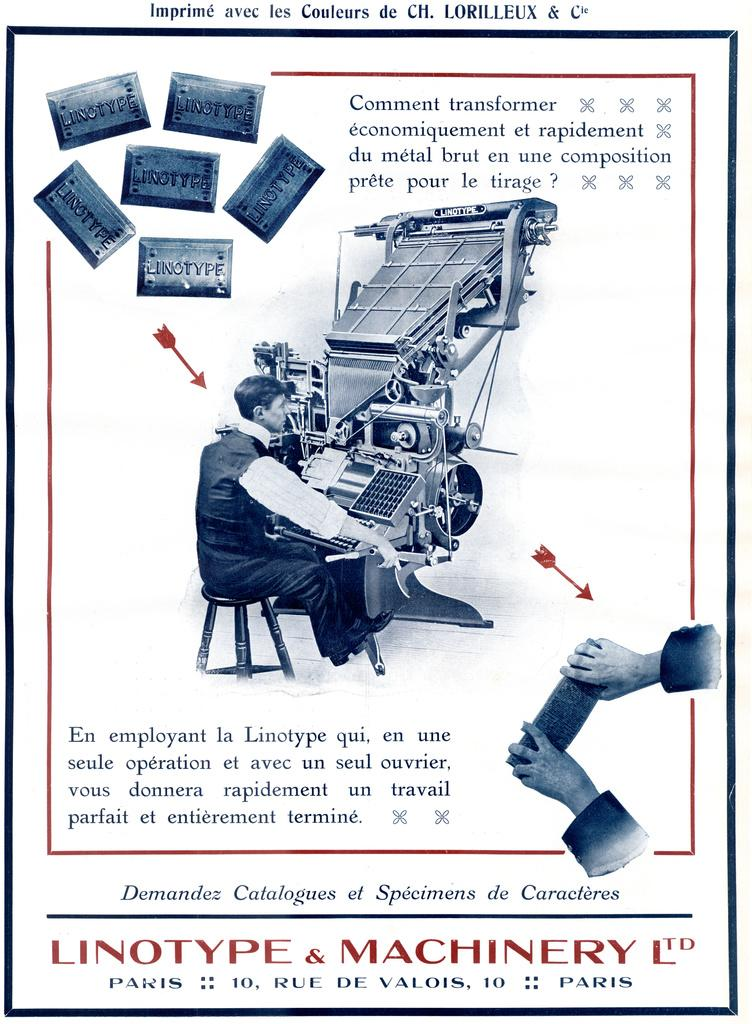What is present on the poster in the image? The poster contains text, images, and objects. Can you describe the text on the poster? Unfortunately, the specific content of the text cannot be determined from the image alone. What types of images are on the poster? The images on the poster cannot be identified from the image alone. What objects are featured on the poster? The objects on the poster cannot be identified from the image alone. How many wrens can be seen flying over the waves in the image? There are no wrens or waves present in the image; it features a poster with text, images, and objects. 